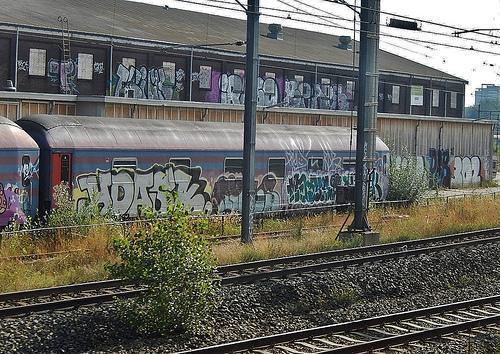How many poles are in the picture?
Give a very brief answer. 2. How many telephone lines are visible in the picture?
Give a very brief answer. 3. How many train tracks are visible?
Give a very brief answer. 2. 